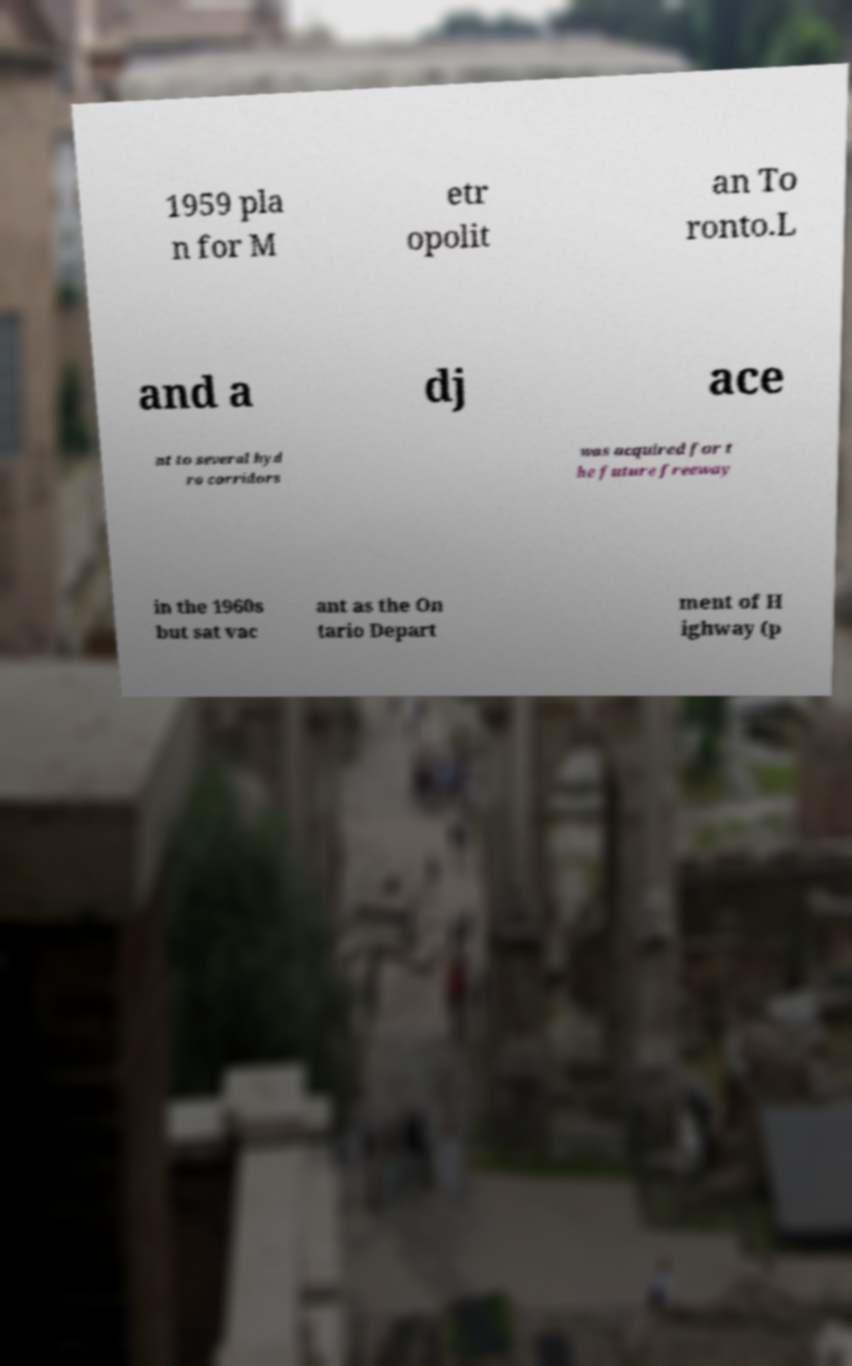Please read and relay the text visible in this image. What does it say? 1959 pla n for M etr opolit an To ronto.L and a dj ace nt to several hyd ro corridors was acquired for t he future freeway in the 1960s but sat vac ant as the On tario Depart ment of H ighway (p 